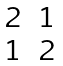Convert formula to latex. <formula><loc_0><loc_0><loc_500><loc_500>\begin{matrix} 2 & 1 \\ 1 & 2 \end{matrix}</formula> 